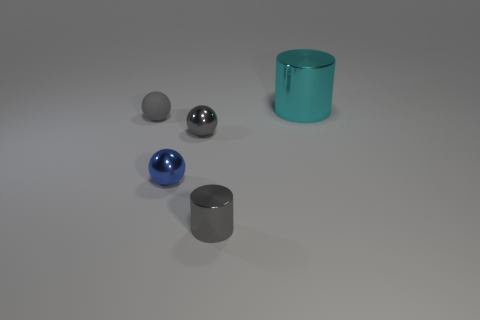What number of balls are either small gray metallic objects or gray rubber things?
Give a very brief answer. 2. What shape is the shiny thing that is behind the blue metallic ball and in front of the large cyan cylinder?
Your answer should be compact. Sphere. Is there a matte sphere that has the same size as the gray rubber object?
Give a very brief answer. No. How many objects are either metallic things in front of the large metallic cylinder or large blue metal spheres?
Offer a very short reply. 3. Is the large cyan cylinder made of the same material as the tiny ball in front of the gray shiny ball?
Your answer should be very brief. Yes. How many other things are there of the same shape as the small blue thing?
Provide a short and direct response. 2. How many objects are either gray objects that are in front of the small blue ball or tiny metal things behind the gray metal cylinder?
Your response must be concise. 3. How many other objects are there of the same color as the rubber object?
Provide a succinct answer. 2. Are there fewer tiny gray things to the right of the large shiny cylinder than cylinders that are on the right side of the small gray shiny cylinder?
Your response must be concise. Yes. What number of tiny red cubes are there?
Give a very brief answer. 0. 